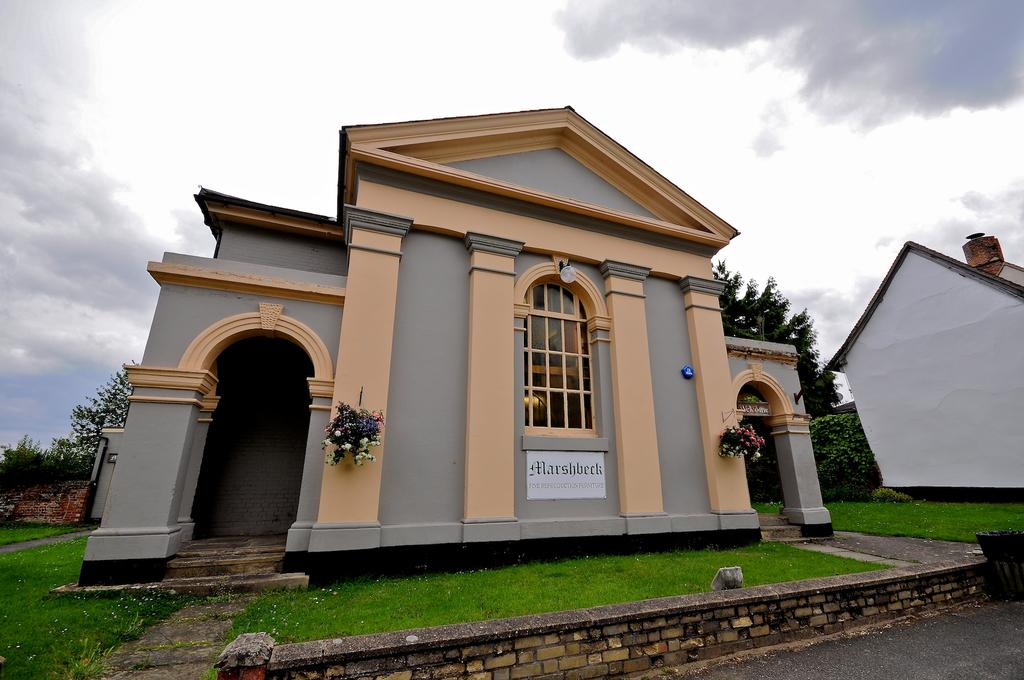What type of structures are visible in the image? There are buildings in the image. What is located in front of the buildings? There is grass in front of the buildings. Is there any barrier or feature between the grass and the buildings? Yes, there is a small wall in front of the grass. What can be seen in the background of the image? There are trees and the sky visible in the background of the image. How many girls are playing with the farmer near the train in the image? There is no train, farmer, or girls present in the image. 